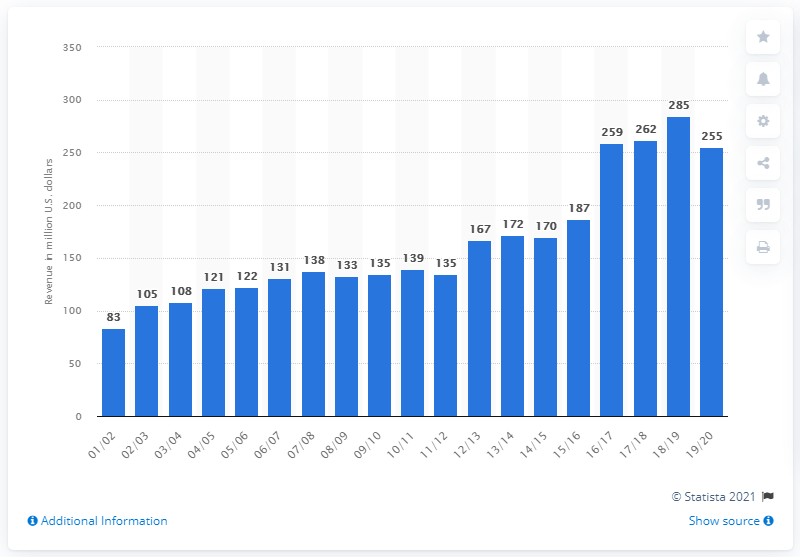Specify some key components in this picture. The estimated revenue of the San Antonio Spurs for the 2019/20 season was approximately 255 million dollars. 